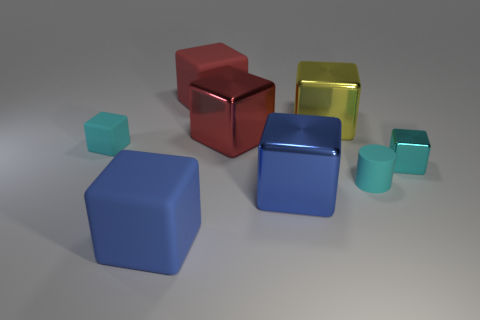Is there a cyan metallic object that is on the left side of the blue object on the left side of the big red matte cube?
Offer a very short reply. No. The cyan rubber object behind the small cyan cylinder has what shape?
Offer a very short reply. Cube. What material is the other tiny cube that is the same color as the tiny matte cube?
Your answer should be compact. Metal. What color is the tiny cube left of the small cyan cube to the right of the large blue rubber thing?
Make the answer very short. Cyan. Do the cyan metal block and the blue rubber object have the same size?
Your answer should be compact. No. What material is the other cyan object that is the same shape as the cyan metal object?
Offer a very short reply. Rubber. What number of red cubes are the same size as the cyan metallic thing?
Make the answer very short. 0. Is the number of cyan cubes less than the number of red matte things?
Your answer should be very brief. No. What number of cyan objects are either small matte cubes or rubber cylinders?
Ensure brevity in your answer.  2. How many matte things are both behind the large blue rubber block and in front of the red matte object?
Keep it short and to the point. 2. 